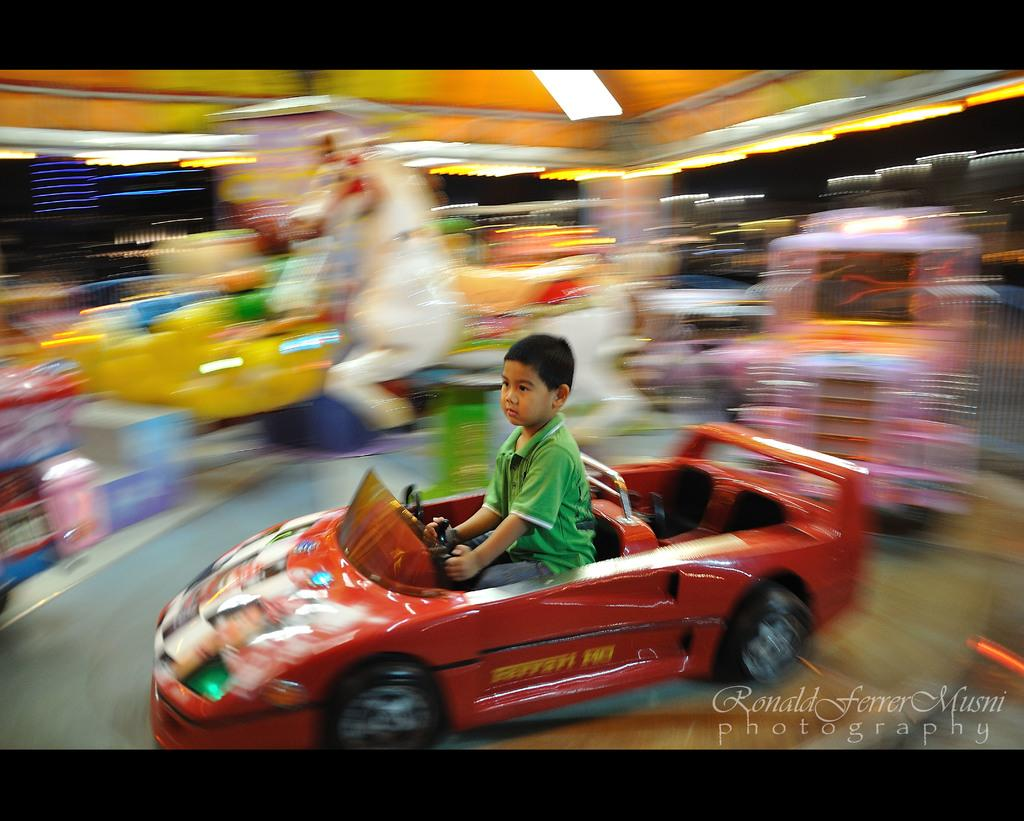Who is the main subject in the image? There is a boy in the image. What is the boy doing in the image? The boy is sitting in a toy car. What else can be seen in the background of the image? There are many toys and some light visible in the background. How many ladybugs are crawling on the boy's wrist in the image? There are no ladybugs present on the boy's wrist in the image. 